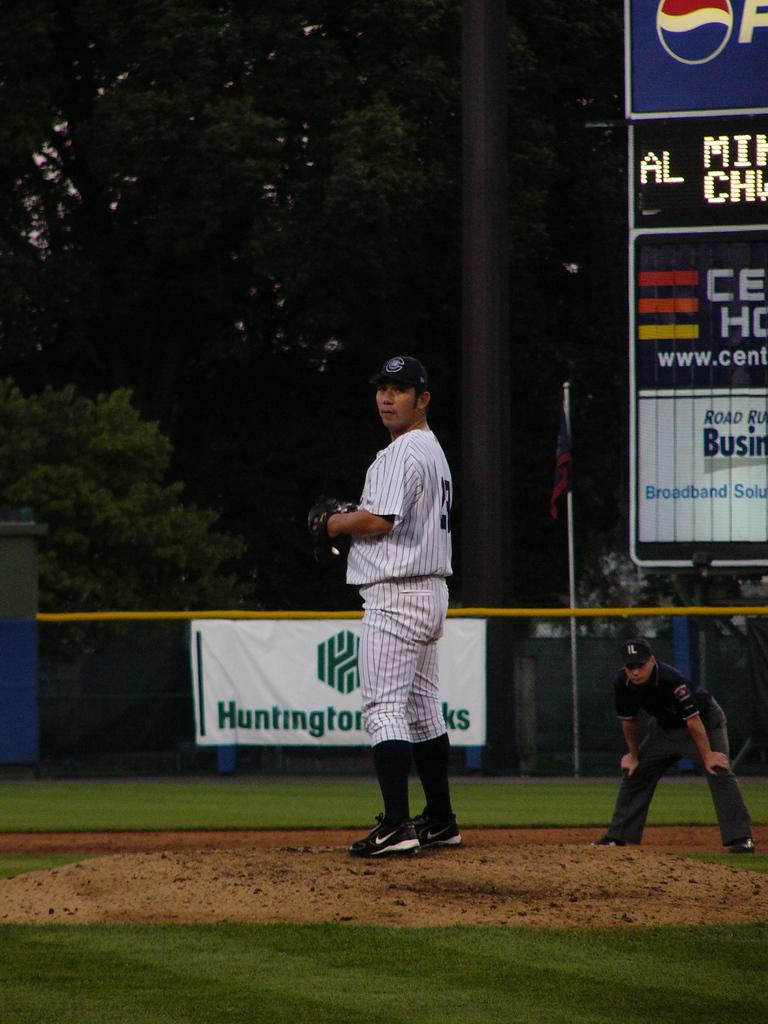What number is the pitcher?
Your answer should be very brief. Unanswerable. Is the word huntington on the sign behind the man?
Make the answer very short. Yes. 